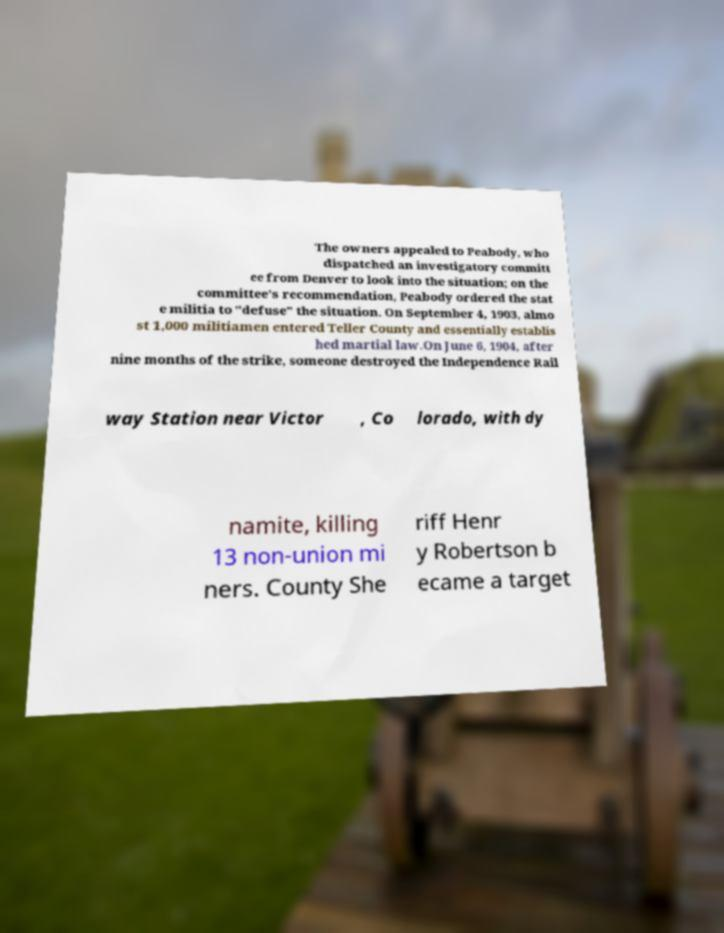What messages or text are displayed in this image? I need them in a readable, typed format. The owners appealed to Peabody, who dispatched an investigatory committ ee from Denver to look into the situation; on the committee's recommendation, Peabody ordered the stat e militia to "defuse" the situation. On September 4, 1903, almo st 1,000 militiamen entered Teller County and essentially establis hed martial law.On June 6, 1904, after nine months of the strike, someone destroyed the Independence Rail way Station near Victor , Co lorado, with dy namite, killing 13 non-union mi ners. County She riff Henr y Robertson b ecame a target 